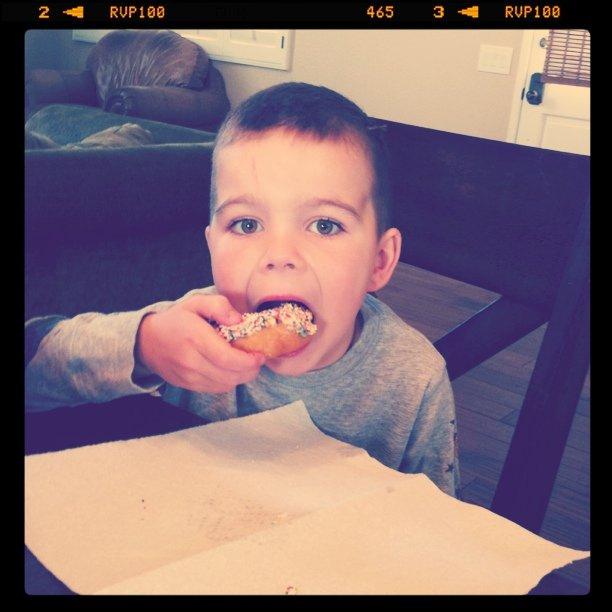What is the boy holding?
Concise answer only. Donut. Is that a boy or a girl?
Quick response, please. Boy. Does the kid have toys?
Be succinct. No. Is the baby eating?
Write a very short answer. Yes. Does the boy need a haircut?
Be succinct. No. Is the boy Caucasian?
Keep it brief. Yes. What is the baby holding?
Write a very short answer. Donut. Is this photograph film or digital?
Give a very brief answer. Digital. What is the kid holding?
Concise answer only. Donut. What is this food called?
Give a very brief answer. Donut. Where was this photo taken?
Keep it brief. Inside. Does the boy look content?
Give a very brief answer. Yes. What is the baby eating?
Short answer required. Donut. What is the boy eating?
Concise answer only. Donut. What is he holding in his hands?
Answer briefly. Donut. What is the young boy holding?
Keep it brief. Donut. Is this a restaurant?
Quick response, please. No. Is this child seated?
Answer briefly. Yes. Is he playing with a computer?
Quick response, please. No. What is the boy wearing?
Concise answer only. Grey shirt. 